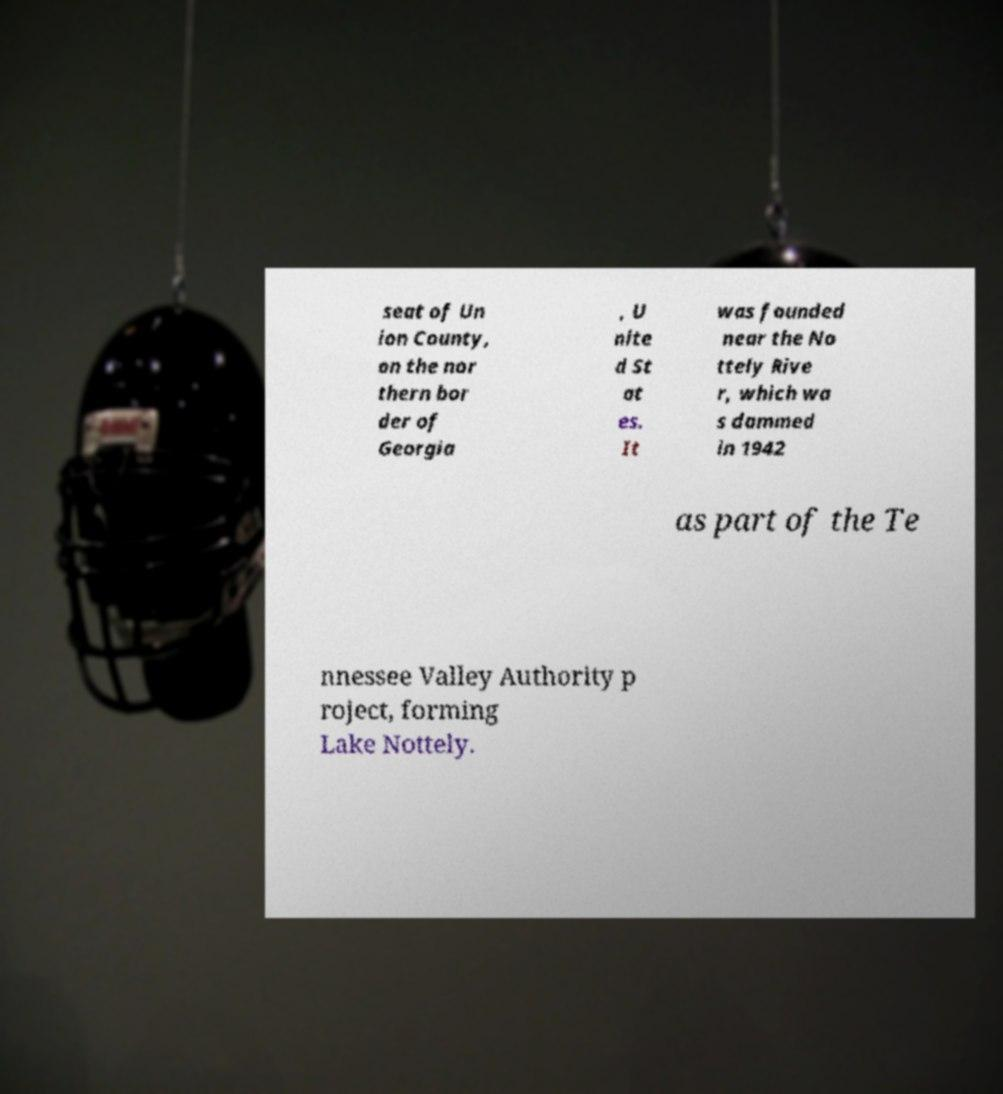Please read and relay the text visible in this image. What does it say? seat of Un ion County, on the nor thern bor der of Georgia , U nite d St at es. It was founded near the No ttely Rive r, which wa s dammed in 1942 as part of the Te nnessee Valley Authority p roject, forming Lake Nottely. 